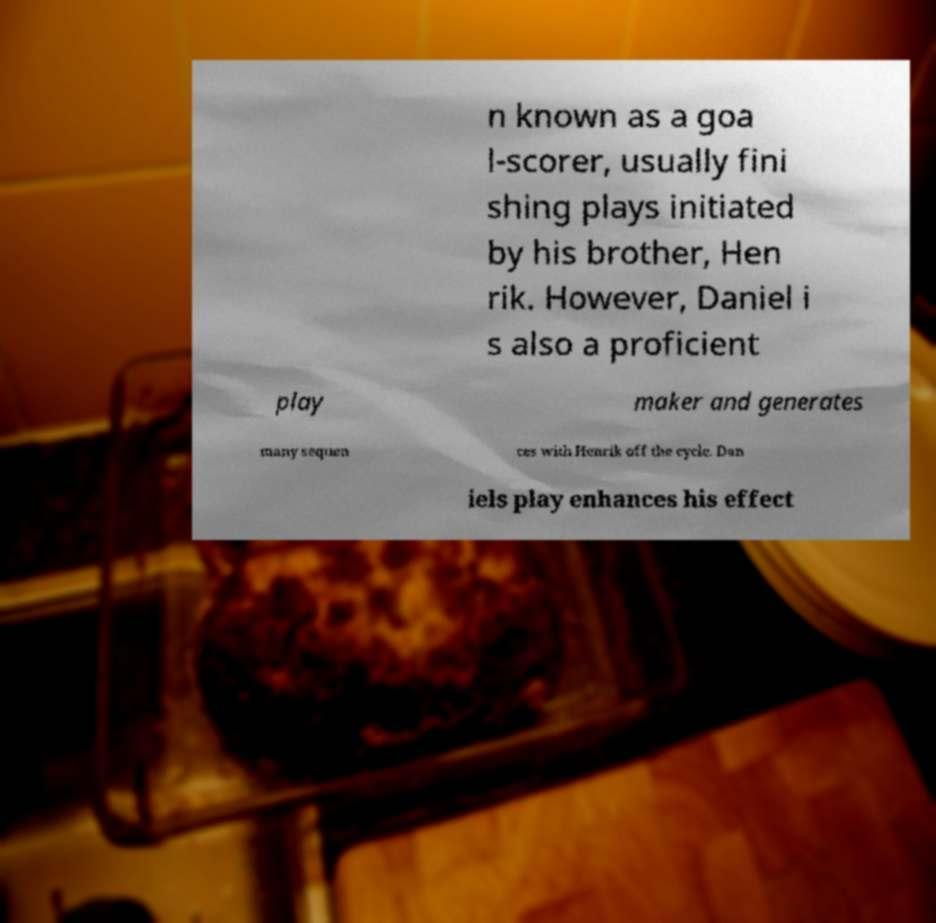Can you accurately transcribe the text from the provided image for me? n known as a goa l-scorer, usually fini shing plays initiated by his brother, Hen rik. However, Daniel i s also a proficient play maker and generates many sequen ces with Henrik off the cycle. Dan iels play enhances his effect 